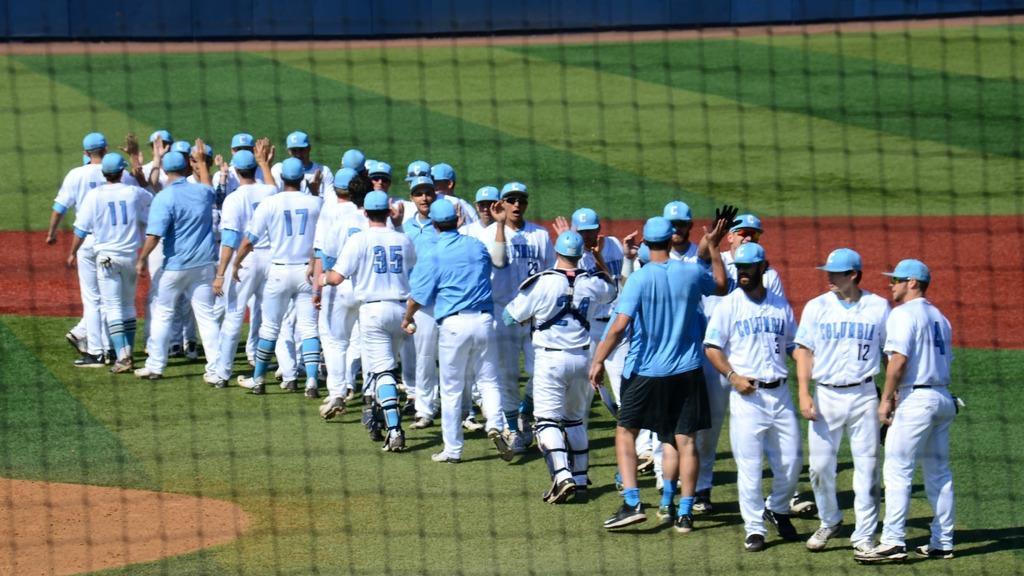Describe this image in one or two sentences. In this picture, we can see a few people, and the ground with grass, and we can see the net. 